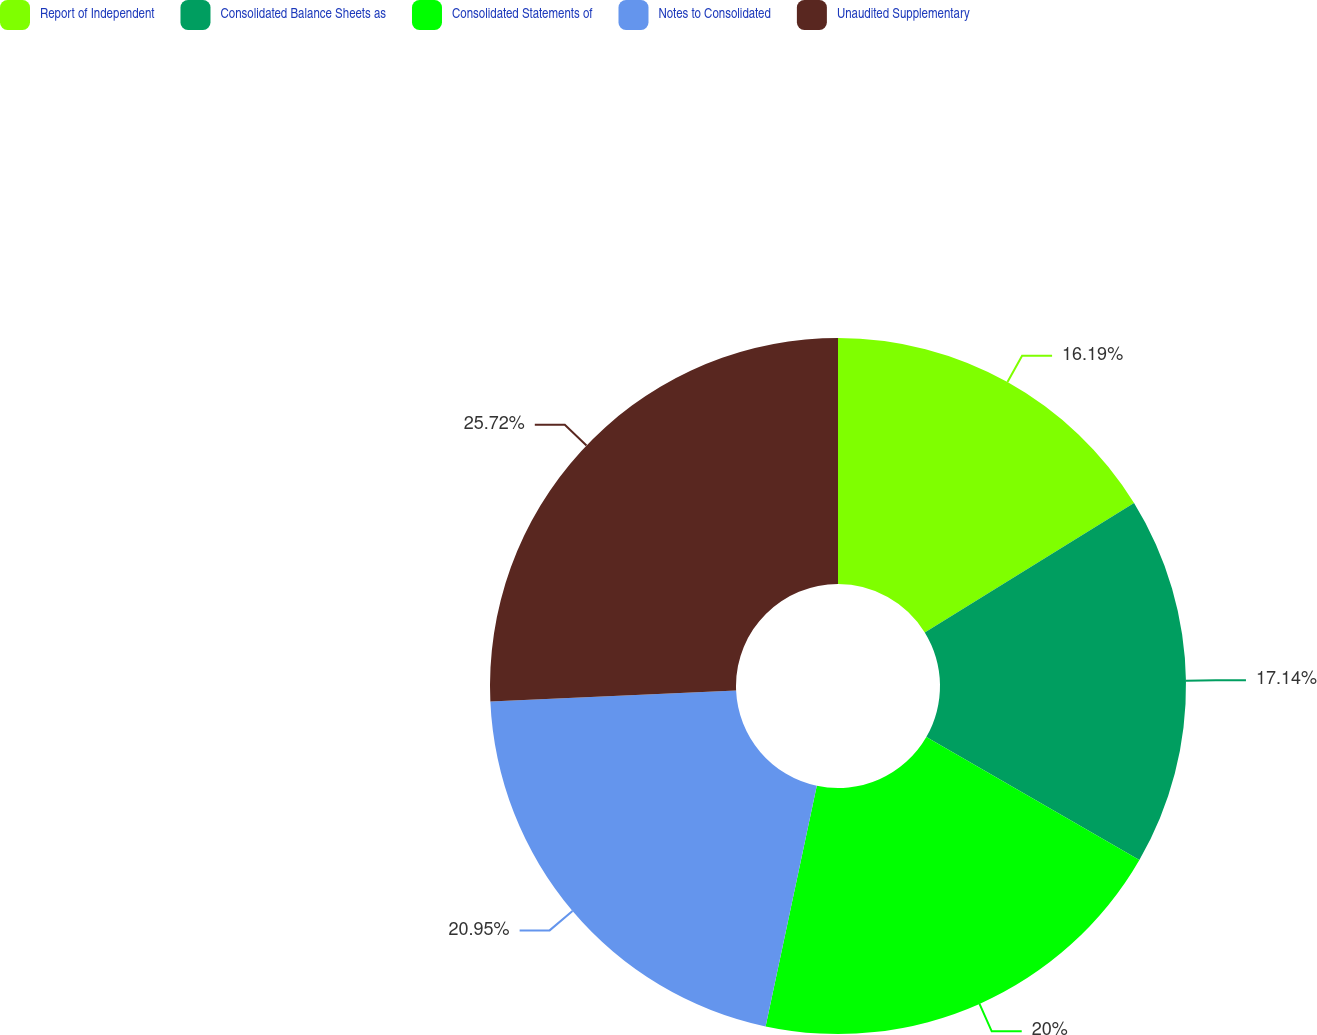Convert chart. <chart><loc_0><loc_0><loc_500><loc_500><pie_chart><fcel>Report of Independent<fcel>Consolidated Balance Sheets as<fcel>Consolidated Statements of<fcel>Notes to Consolidated<fcel>Unaudited Supplementary<nl><fcel>16.19%<fcel>17.14%<fcel>20.0%<fcel>20.95%<fcel>25.71%<nl></chart> 